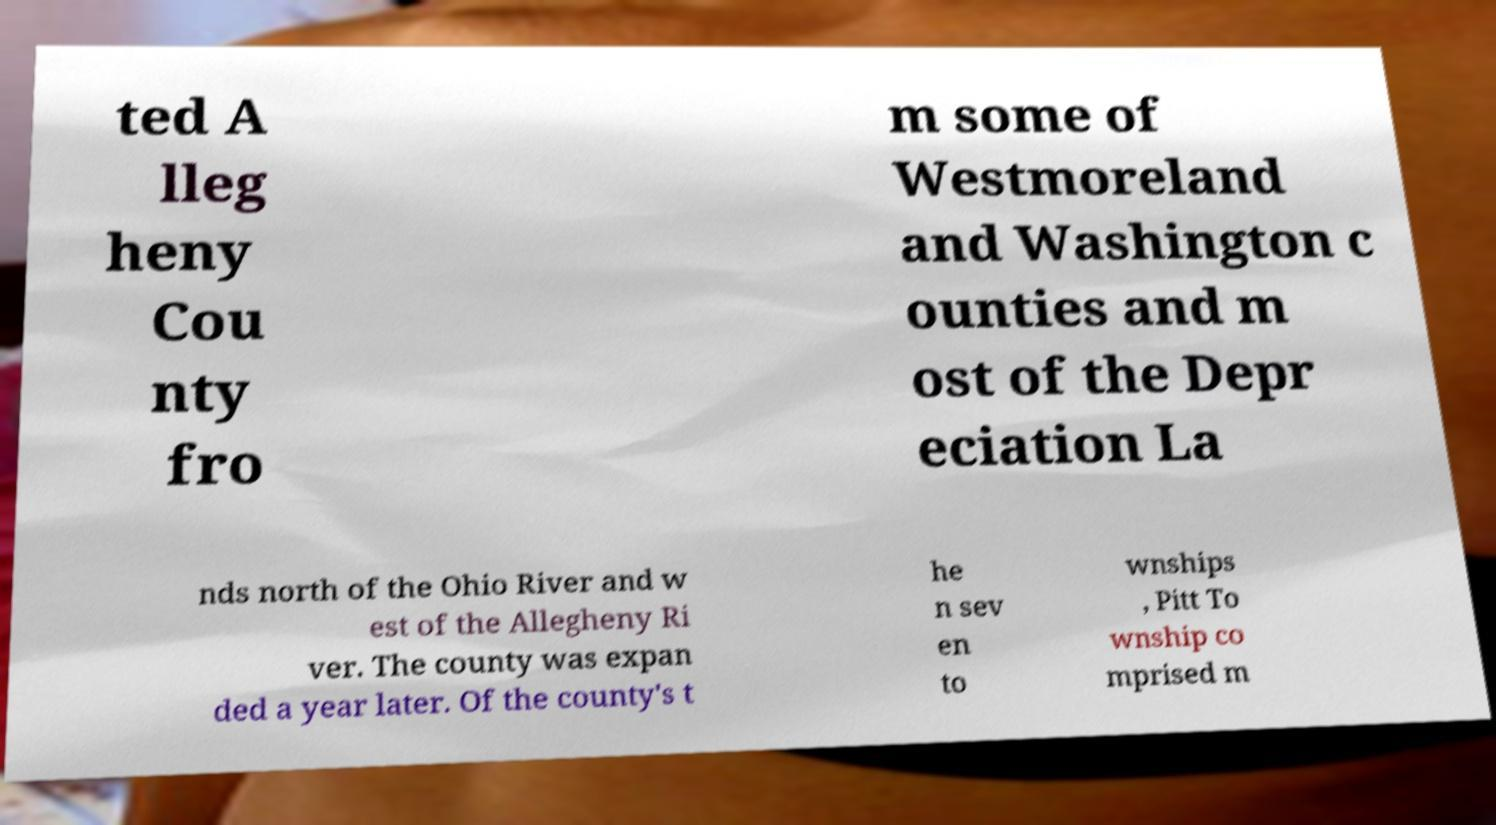Please read and relay the text visible in this image. What does it say? ted A lleg heny Cou nty fro m some of Westmoreland and Washington c ounties and m ost of the Depr eciation La nds north of the Ohio River and w est of the Allegheny Ri ver. The county was expan ded a year later. Of the county's t he n sev en to wnships , Pitt To wnship co mprised m 